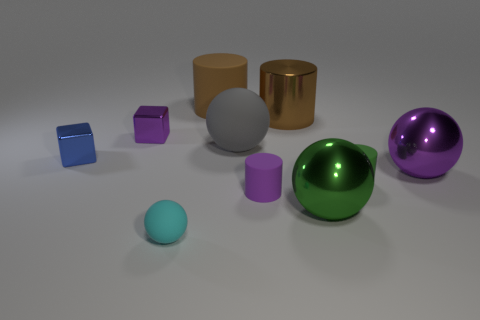What size is the blue cube that is the same material as the big purple ball?
Your answer should be very brief. Small. There is a small matte cylinder that is left of the tiny matte object that is right of the big green ball; what is its color?
Ensure brevity in your answer.  Purple. How many tiny purple cubes have the same material as the cyan thing?
Give a very brief answer. 0. What number of metallic things are blocks or tiny yellow blocks?
Offer a terse response. 2. There is a gray sphere that is the same size as the green metal sphere; what material is it?
Offer a terse response. Rubber. Is there a cylinder that has the same material as the large green sphere?
Your answer should be compact. Yes. What shape is the tiny purple thing that is behind the cube in front of the tiny purple thing that is left of the cyan matte ball?
Offer a very short reply. Cube. There is a brown matte object; does it have the same size as the purple metallic thing to the left of the big metal cylinder?
Provide a succinct answer. No. What shape is the thing that is both right of the tiny purple matte cylinder and behind the purple metal cube?
Your response must be concise. Cylinder. What number of tiny objects are either cyan rubber spheres or blue metallic things?
Your answer should be compact. 2. 